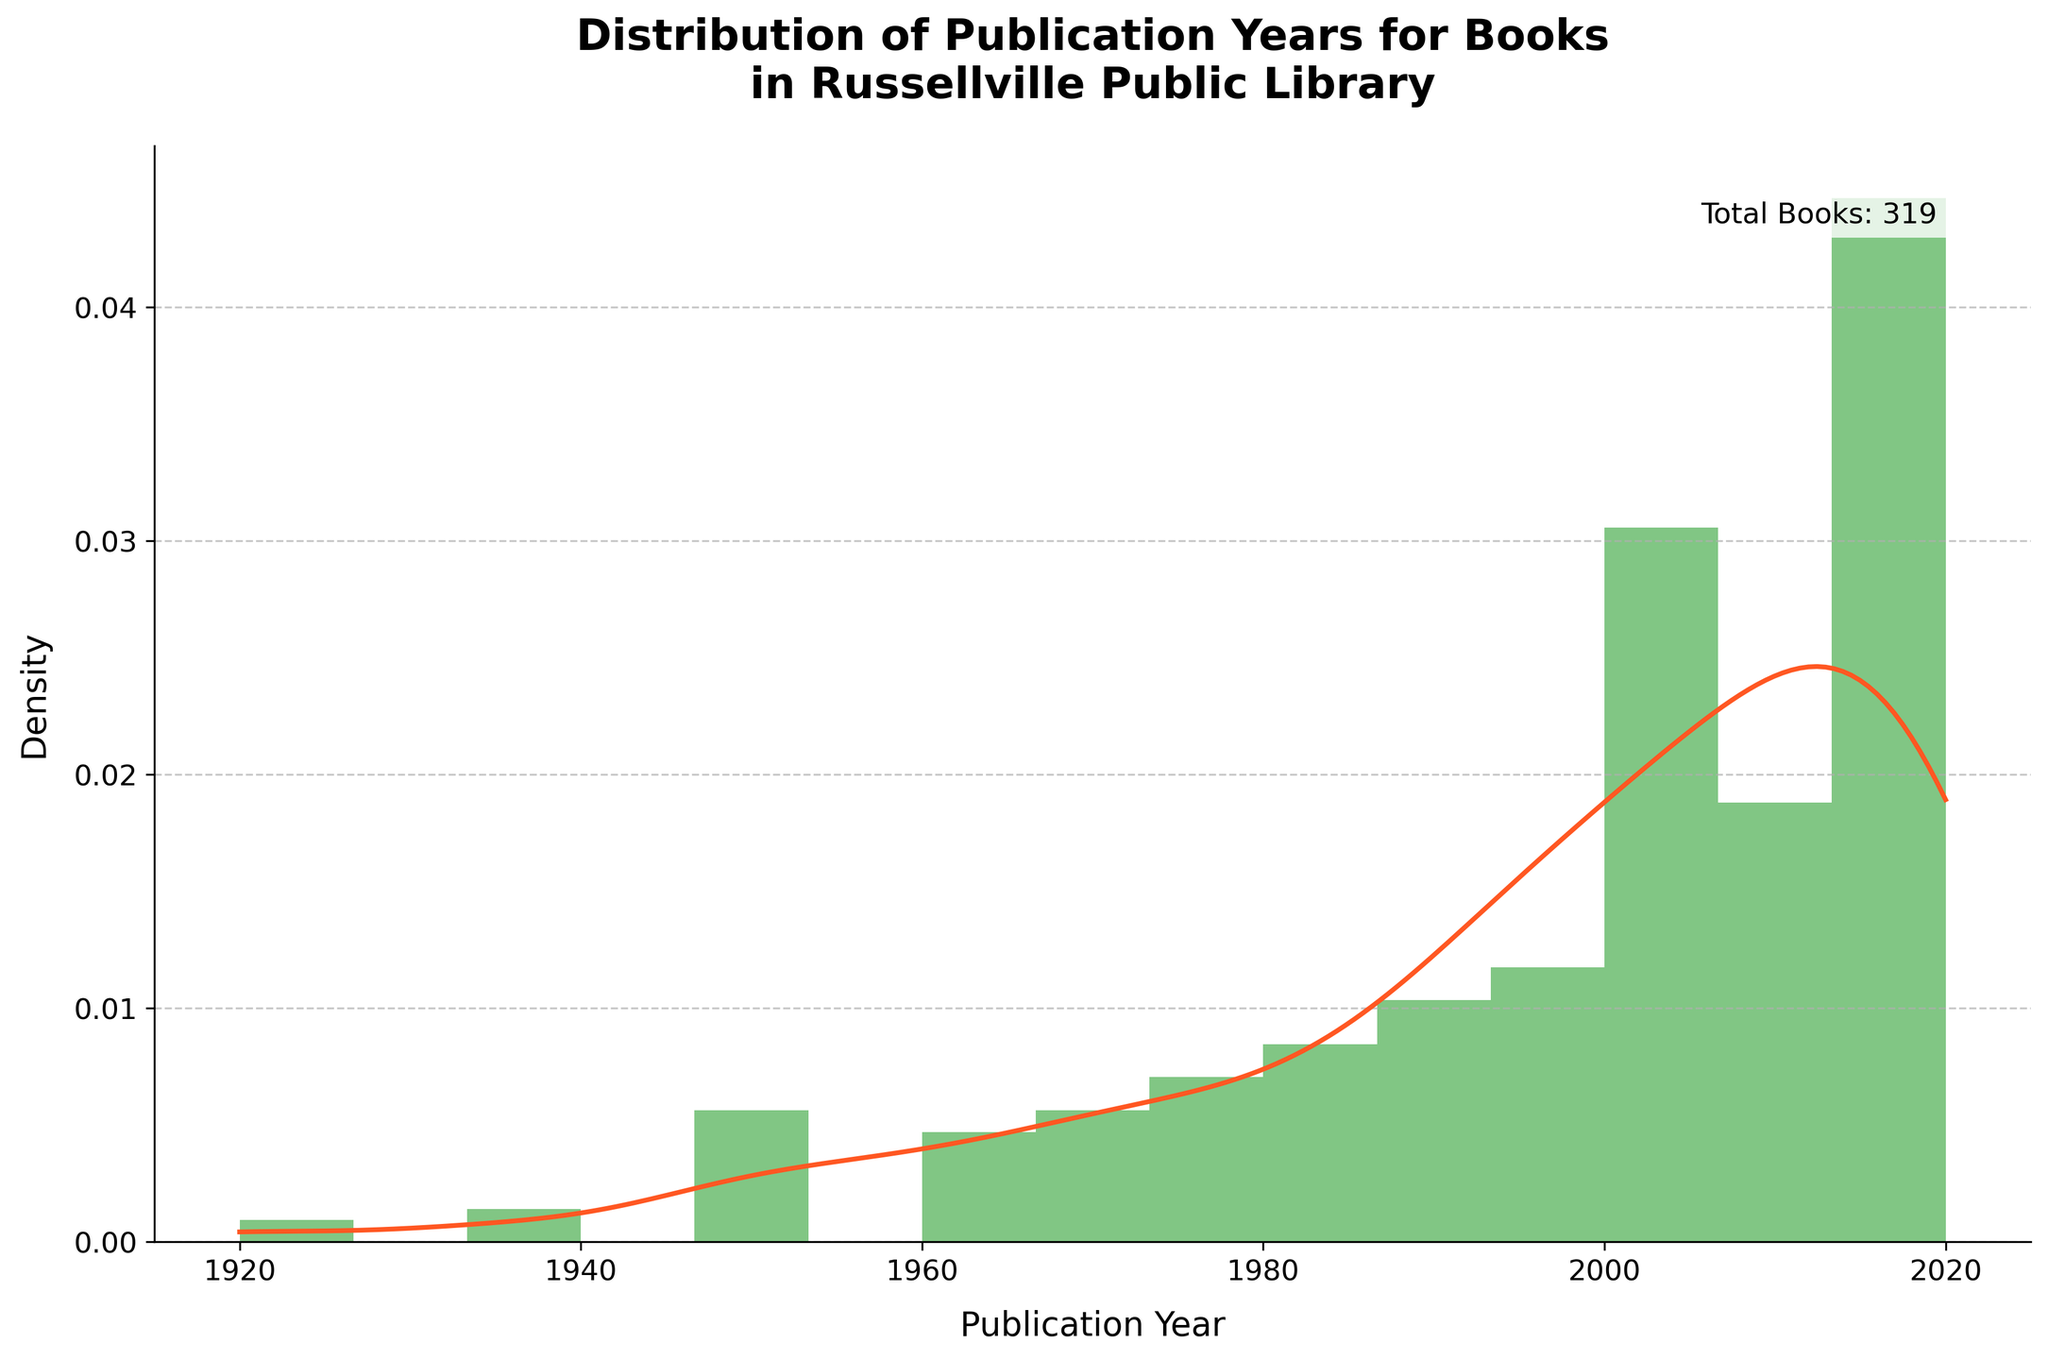What is the title of the plot? The title of the plot can be found at the top center of the figure. It reads "Distribution of Publication Years for Books in Russellville Public Library".
Answer: Distribution of Publication Years for Books in Russellville Public Library How many total books are represented in the figure? The total number of books is annotated as text within the plot. It reads "Total Books: 314".
Answer: 314 What color represents the histogram in the plot? The color of the histogram bars can be visually identified. The bars are a shade of green.
Answer: Green Which publication year has the highest density according to the KDE curve? The KDE (density curve) peaks at the highest point, which can be visually traced down to the corresponding year on the x-axis. The peak appears around 2020.
Answer: 2020 What is the range of publication years covered in the figure? The x-axis of the plot shows publication years ranging from the earliest to the latest. The range is from 1920 to 2020.
Answer: 1920 to 2020 Which decade appears to have the largest number of publications based on the histogram? Each bar in the histogram represents the density of books published in that year. By visually comparing the height of the bars grouped by decade, the 2010s has the highest density overall.
Answer: 2010s Compare the density of publications between 1950 and 1960. Which one is higher? Looking at the heights of the bars between 1950 and 1960 on the histogram as well as the KDE curve, the density around 1960 is higher.
Answer: 1960 How does the publication density change from 1920 to 2020? Observing the KDE curve from left to right, the publication density starts low, increases gradually, peaks around 2020, indicating increasing frequency of publications over time.
Answer: Increases gradually Is there any decade without any publications? Looking at the histogram, there are bars for every decade, indicating there are no decades without publications.
Answer: No Compare the density between the years 1947 and 1983. Which one is higher, and by how much? The densities at 1947 and 1983 can be compared by looking at the heights of corresponding bars. The density at 1983 is higher, and there is a noticeable difference when visually compared.
Answer: 1983, significantly higher 